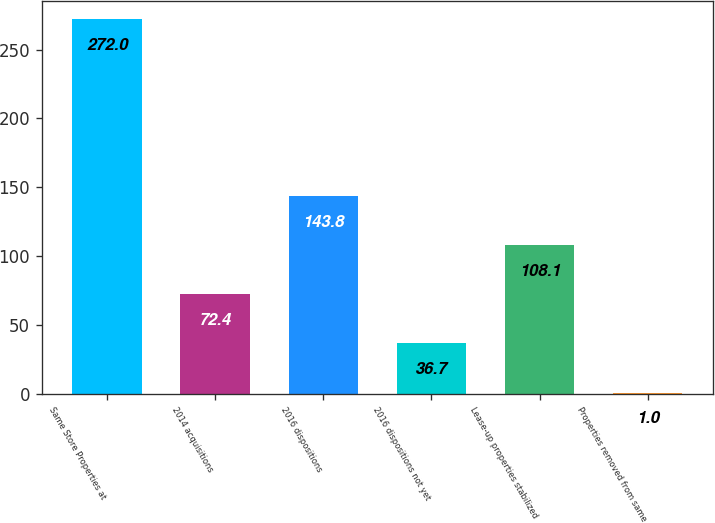Convert chart to OTSL. <chart><loc_0><loc_0><loc_500><loc_500><bar_chart><fcel>Same Store Properties at<fcel>2014 acquisitions<fcel>2016 dispositions<fcel>2016 dispositions not yet<fcel>Lease-up properties stabilized<fcel>Properties removed from same<nl><fcel>272<fcel>72.4<fcel>143.8<fcel>36.7<fcel>108.1<fcel>1<nl></chart> 